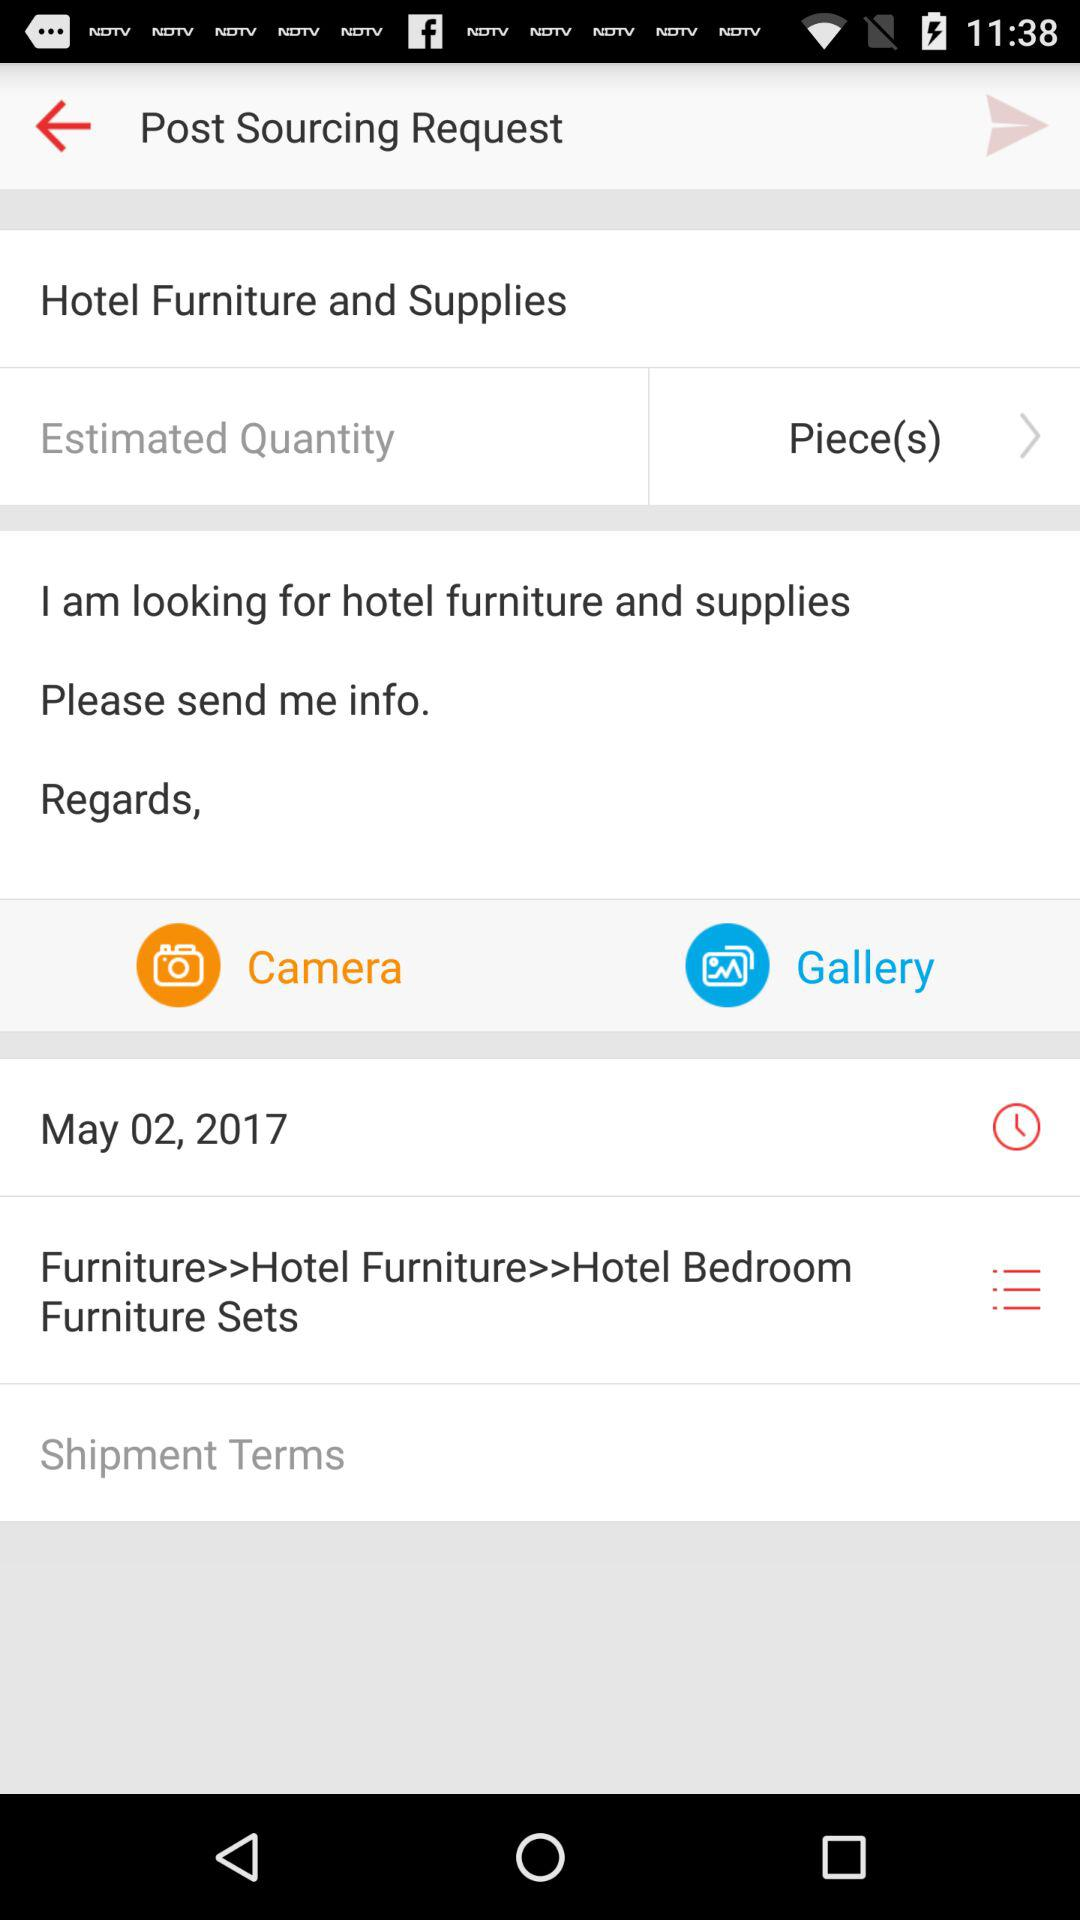What is the date? The date is May 2, 2017. 